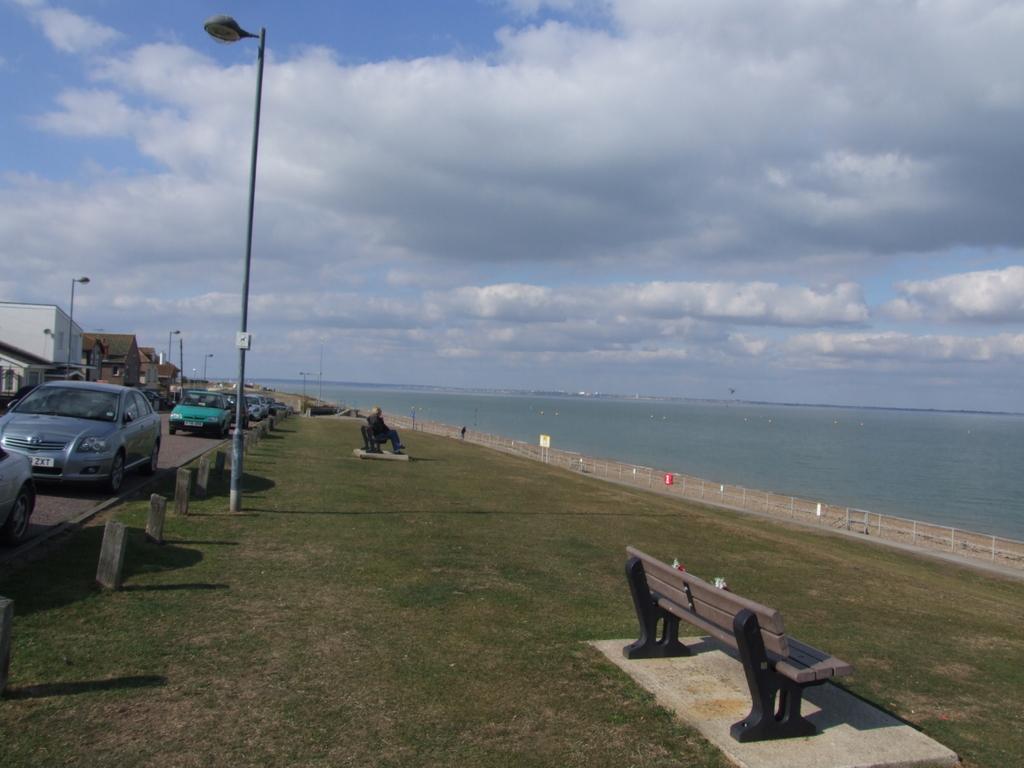Describe this image in one or two sentences. In the image we can see there are many vehicle, light pole, person sitting on a bench, river and cloudy sky. 